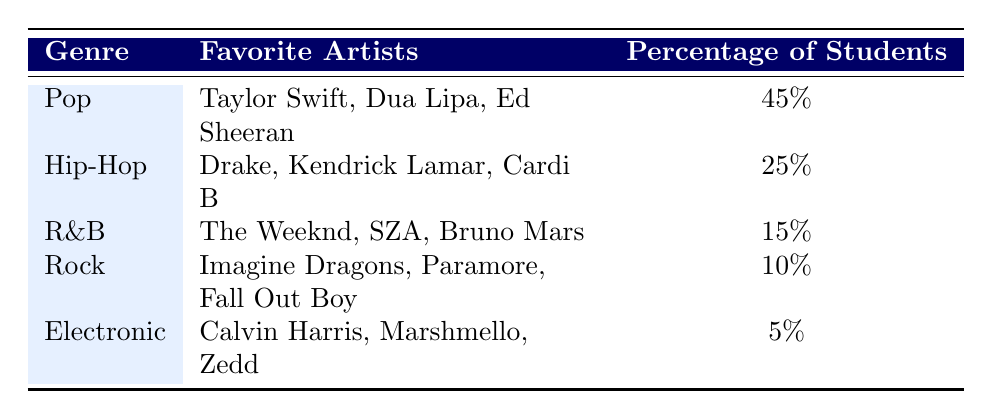What's the most popular music genre among college students based on the survey? The survey results show that Pop is the most popular music genre, with 45% of students favoring it, which is higher than any other genre listed.
Answer: Pop Which artists are favored in the Hip-Hop genre? According to the table, the popular artists in the Hip-Hop genre are Drake, Kendrick Lamar, and Cardi B.
Answer: Drake, Kendrick Lamar, Cardi B What percentage of students like Electronic music? The table states that 5% of students favor Electronic music, which is the lowest percentage among the listed genres.
Answer: 5% If we combine the percentages of R&B and Rock genres, what total percentage do we get? The total percentage for R&B is 15%, and for Rock, it is 10%. Adding these together gives 15 + 10 = 25%.
Answer: 25% Is it true that more students prefer R&B than Electronic music? Yes, the table indicates that 15% of students prefer R&B, while only 5% prefer Electronic music. Therefore, more students like R&B.
Answer: Yes What is the percentage gap between the most favored genre and the least favored genre? The most favored genre is Pop with 45%, and the least favored genre is Electronic with 5%. The gap is therefore 45 - 5 = 40%.
Answer: 40% How many students prefer Hip-Hop compared to those who favor R&B? The percentage of students who prefer Hip-Hop is 25%, and for R&B, it is 15%. To find the difference, we subtract: 25 - 15 = 10%. Therefore, 10% more students prefer Hip-Hop than R&B.
Answer: 10% Which genre has the least number of students favoring it? The Electronic genre has the least number of students favoring it, with only 5% indicating it as their favorite music genre.
Answer: Electronic What are the favorite artists for the Pop genre? The survey specifies that the favorite artists for the Pop genre are Taylor Swift, Dua Lipa, and Ed Sheeran.
Answer: Taylor Swift, Dua Lipa, Ed Sheeran 